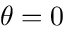<formula> <loc_0><loc_0><loc_500><loc_500>\theta = 0</formula> 